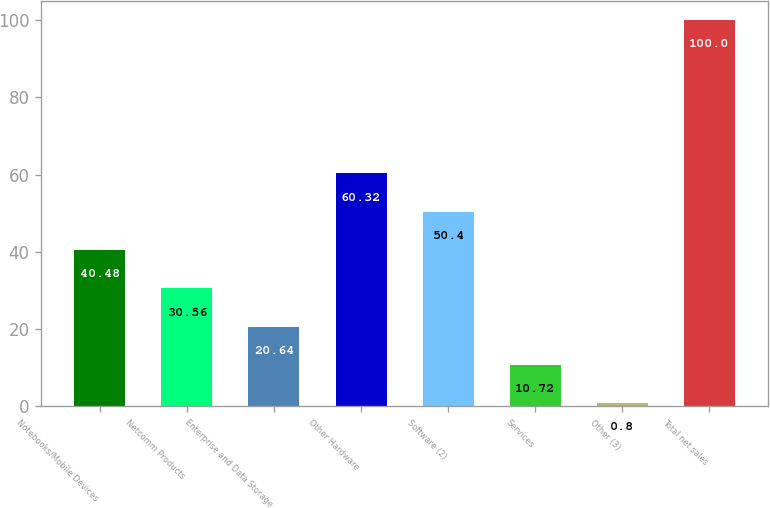Convert chart to OTSL. <chart><loc_0><loc_0><loc_500><loc_500><bar_chart><fcel>Notebooks/Mobile Devices<fcel>Netcomm Products<fcel>Enterprise and Data Storage<fcel>Other Hardware<fcel>Software (2)<fcel>Services<fcel>Other (3)<fcel>Total net sales<nl><fcel>40.48<fcel>30.56<fcel>20.64<fcel>60.32<fcel>50.4<fcel>10.72<fcel>0.8<fcel>100<nl></chart> 